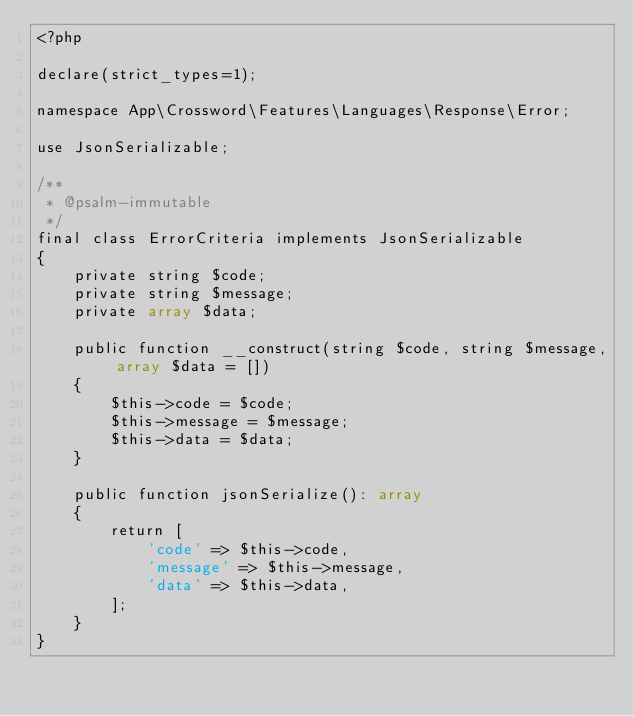Convert code to text. <code><loc_0><loc_0><loc_500><loc_500><_PHP_><?php

declare(strict_types=1);

namespace App\Crossword\Features\Languages\Response\Error;

use JsonSerializable;

/**
 * @psalm-immutable
 */
final class ErrorCriteria implements JsonSerializable
{
    private string $code;
    private string $message;
    private array $data;

    public function __construct(string $code, string $message, array $data = [])
    {
        $this->code = $code;
        $this->message = $message;
        $this->data = $data;
    }

    public function jsonSerialize(): array
    {
        return [
            'code' => $this->code,
            'message' => $this->message,
            'data' => $this->data,
        ];
    }
}
</code> 